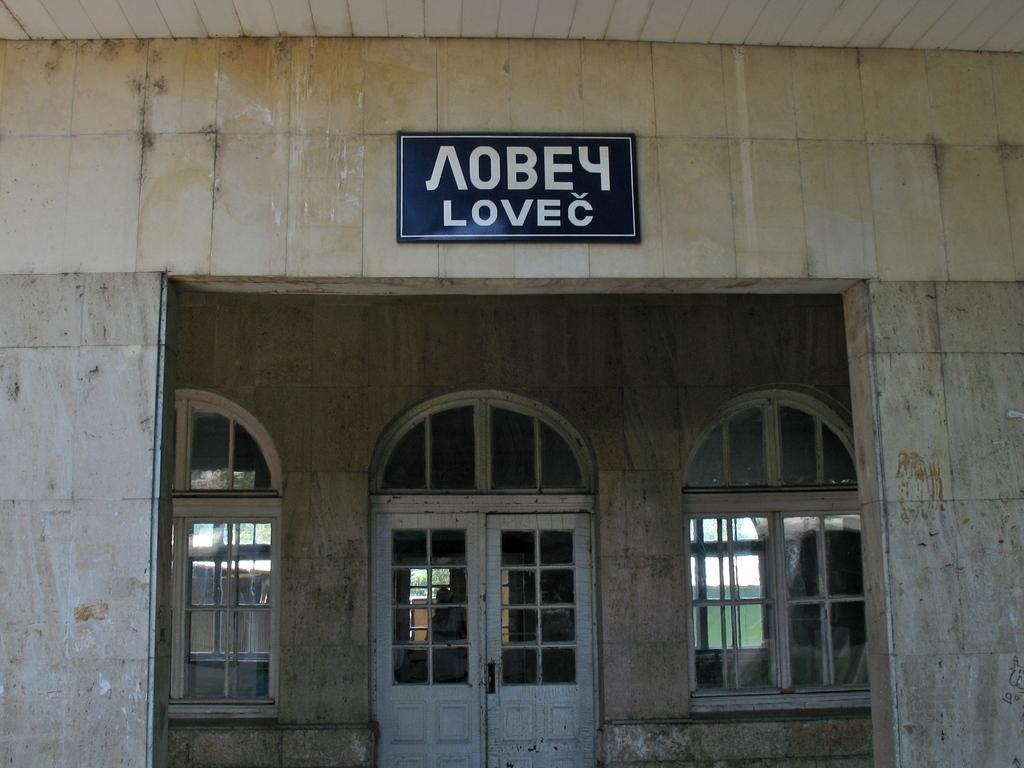What type of structure can be seen in the image? There is a door in the image. What objects are visible on the door? There are glasses and a board on the door. What type of surface is present in the image? There is a wall in the image. What type of pie is being served on the board in the image? There is no pie present in the image; it features a door with glasses and a board. What type of songs can be heard playing in the background of the image? There is no audio or indication of music in the image; it only shows a door with glasses and a board on a wall. 